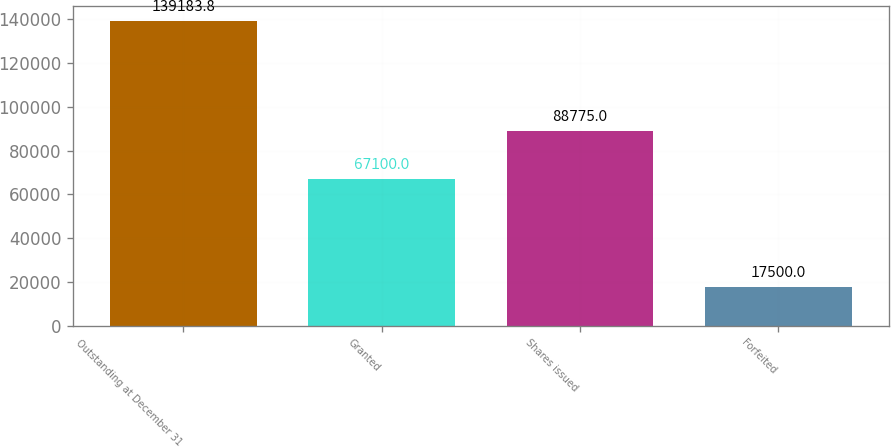Convert chart. <chart><loc_0><loc_0><loc_500><loc_500><bar_chart><fcel>Outstanding at December 31<fcel>Granted<fcel>Shares issued<fcel>Forfeited<nl><fcel>139184<fcel>67100<fcel>88775<fcel>17500<nl></chart> 